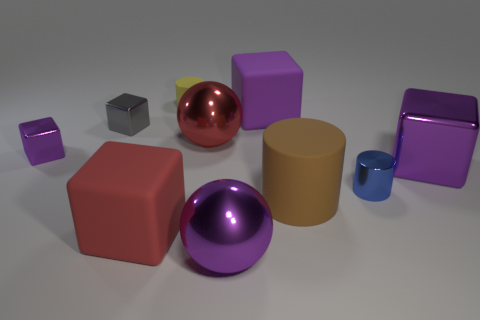Is there any other thing that is the same material as the large red block?
Provide a short and direct response. Yes. There is a yellow matte object that is the same shape as the tiny blue metallic thing; what size is it?
Provide a succinct answer. Small. What is the color of the large thing that is both to the right of the red matte cube and in front of the large brown rubber thing?
Provide a short and direct response. Purple. Is the material of the brown cylinder the same as the large ball that is behind the big brown cylinder?
Give a very brief answer. No. Are there fewer gray shiny objects behind the big purple metal block than big yellow matte cubes?
Provide a succinct answer. No. How many other objects are the same shape as the big brown matte thing?
Offer a terse response. 2. Is there anything else of the same color as the big rubber cylinder?
Give a very brief answer. No. There is a small metal cylinder; is it the same color as the large thing behind the small gray cube?
Make the answer very short. No. What number of other objects are there of the same size as the brown cylinder?
Your answer should be compact. 5. What size is the metallic sphere that is the same color as the large metallic cube?
Your response must be concise. Large. 